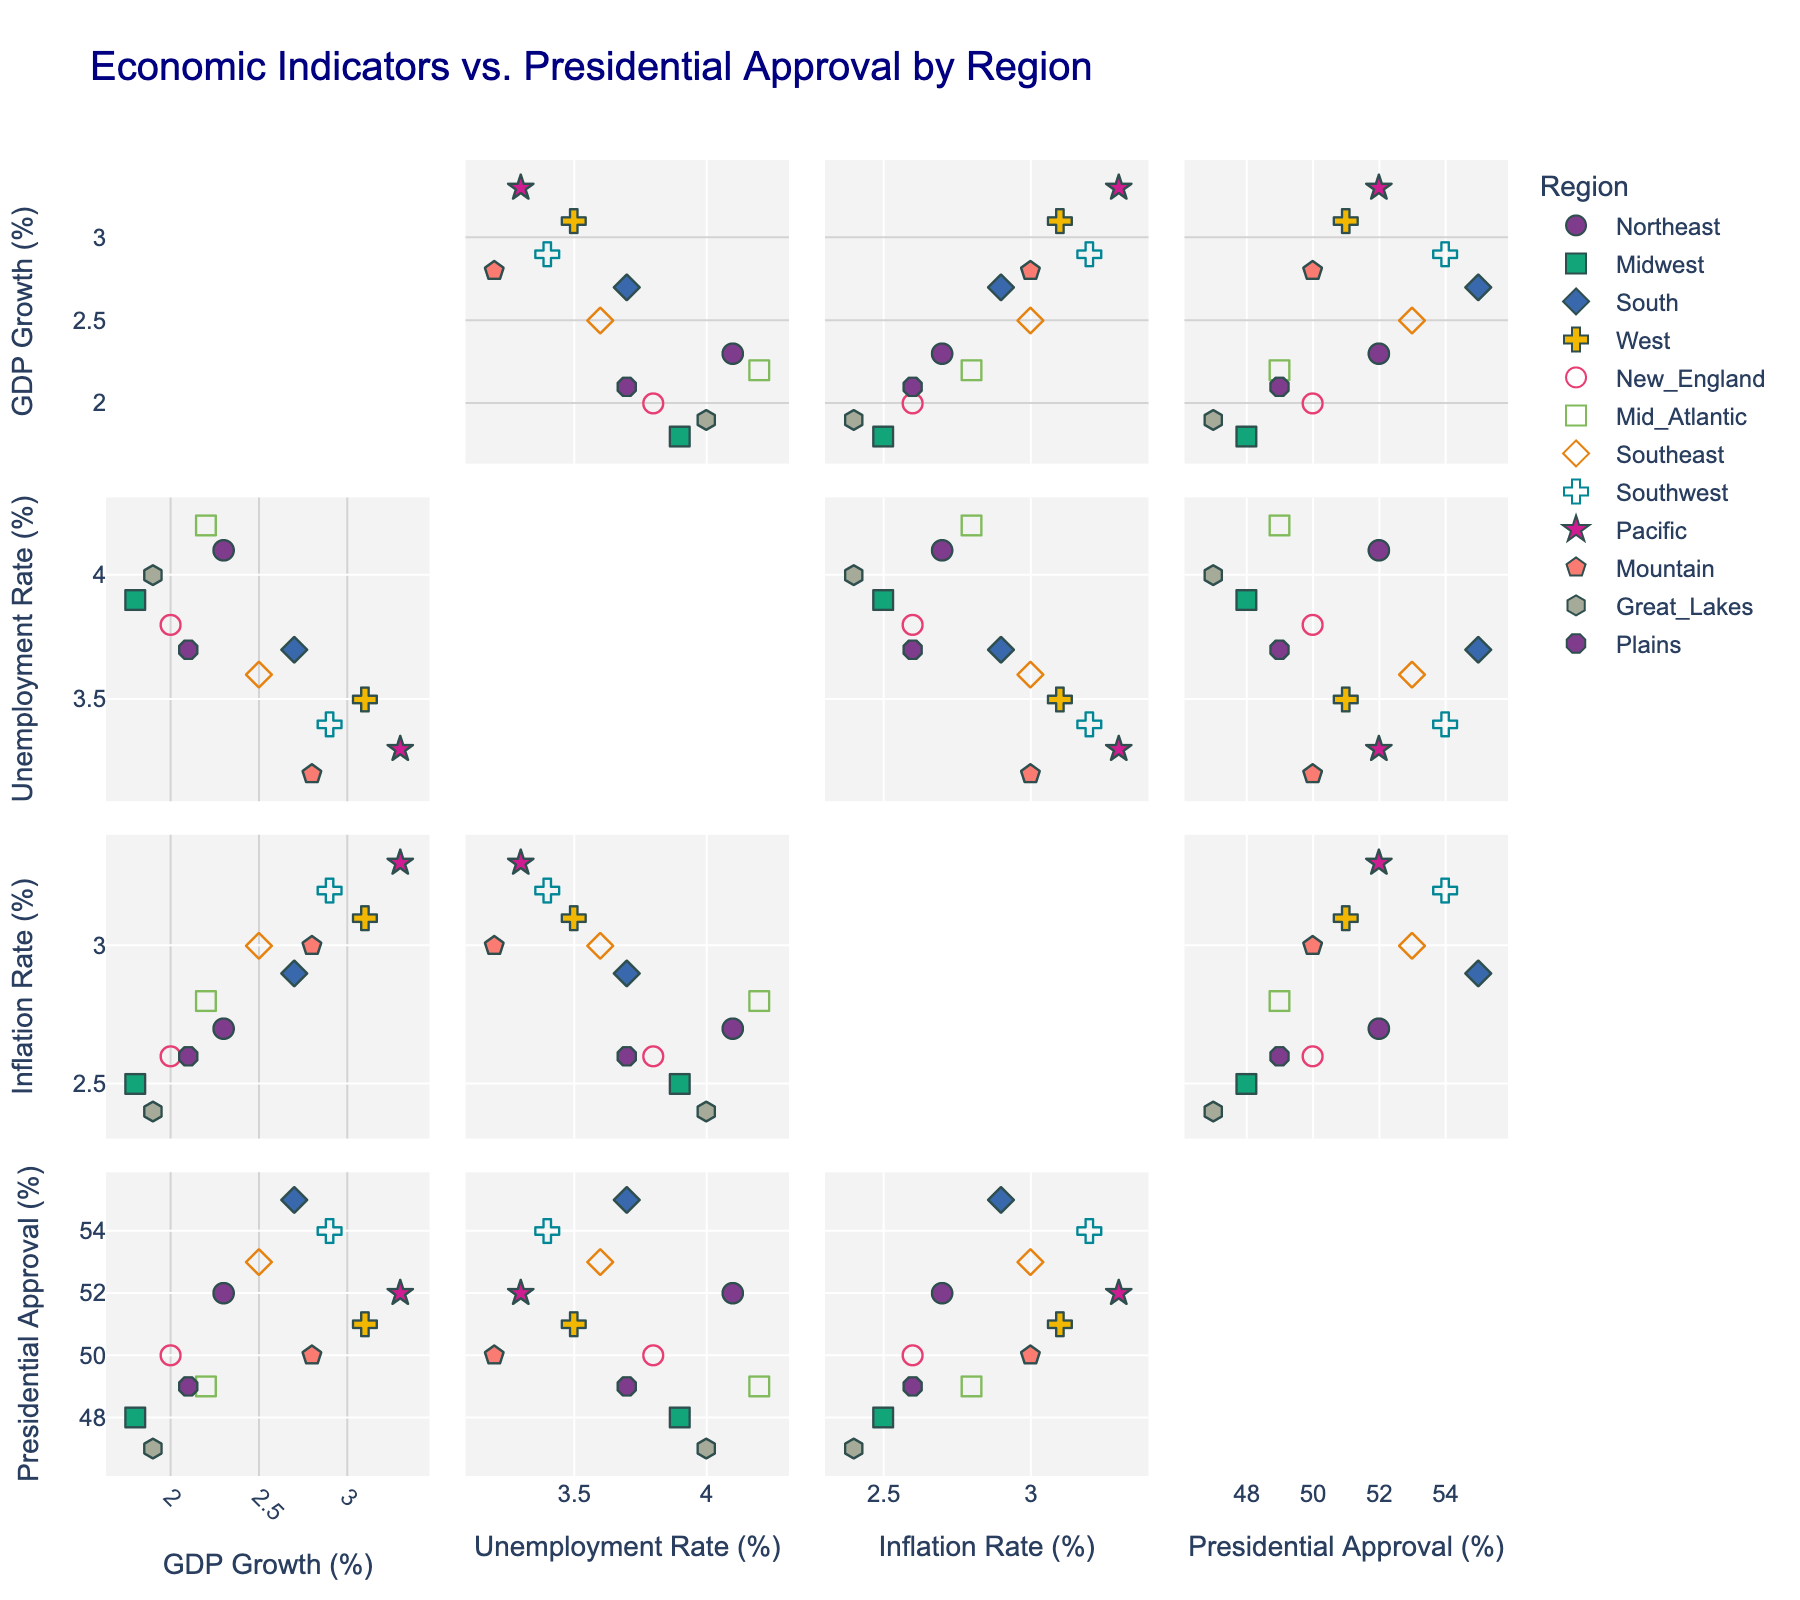What is the title of the figure? The title of the figure is displayed at the top of the plot. It helps in understanding the general context or purpose of the plot. Based on the provided code, the title is "Fiber Optic Cable Deployment Progress by State".
Answer: Fiber Optic Cable Deployment Progress by State Which state showed the greatest increase in fiber optic cable deployment from 2018 to 2023? To determine the state with the greatest increase, subtract the 2018 deployment percentage from the 2023 deployment percentage for each state. The state with the highest result is the one with the greatest increase.
Answer: California What was the percentage deployment progress for Texas in 2020? Locate the year 2020 on the X-axis and note the corresponding Y-axis value for Texas.
Answer: 51% Between 2018 and 2023, which state had the smallest increase in deployment percentage? Calculate the difference between the 2023 and 2018 values for each state. The state with the smallest difference had the smallest increase in deployment percentage.
Answer: Florida Which state had the highest deployment percentage in 2023? Look at the last (2023) data points on the Y-axis of each subplot and identify the highest one.
Answer: California In which year did Illinois meet the 70% deployment milestone? Scan the Illinois subplot to find the first year where the deployment percentage reached or exceeded 70%.
Answer: 2021 Is there any year where all states showed a deployment percentage greater than 50%? Examine the subplots year by year to see if all states have deployment percentages above 50% for any particular year.
Answer: No What is the average deployment percentage of Florida over the years 2018 to 2023? Add the yearly percentages for Florida from 2018 to 2023 and then divide by the number of years (6). (31+42+54+67+79+88)/6 = 60.17
Answer: 60.17 How many states have deployment percentages above 80% in 2022? Check the 2022 values for each state and count how many are above 80%.
Answer: Three Which state shows the most consistent yearly increase in deployment percentage? Assess the slopes of the lines in each subplot. The most consistent line (without sudden jumps or declines) indicates the state with the most consistent yearly increases.
Answer: Texas 